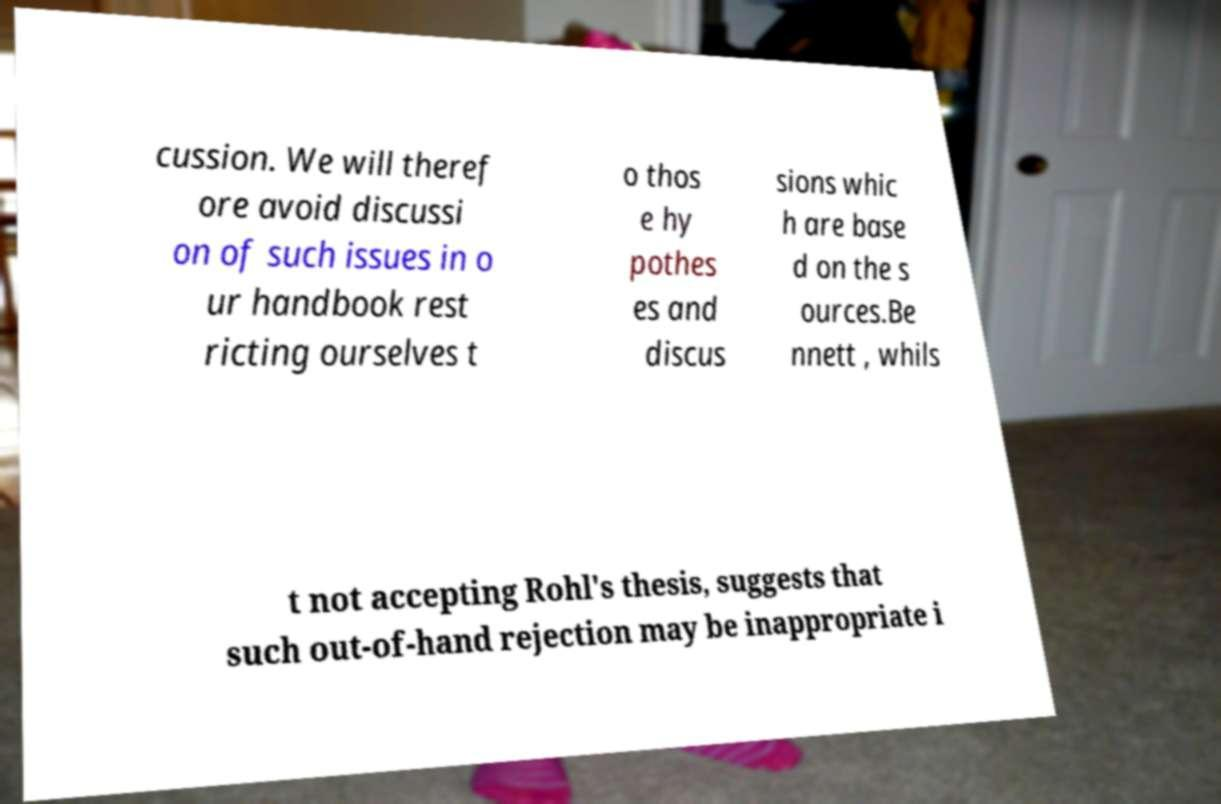Please identify and transcribe the text found in this image. cussion. We will theref ore avoid discussi on of such issues in o ur handbook rest ricting ourselves t o thos e hy pothes es and discus sions whic h are base d on the s ources.Be nnett , whils t not accepting Rohl's thesis, suggests that such out-of-hand rejection may be inappropriate i 